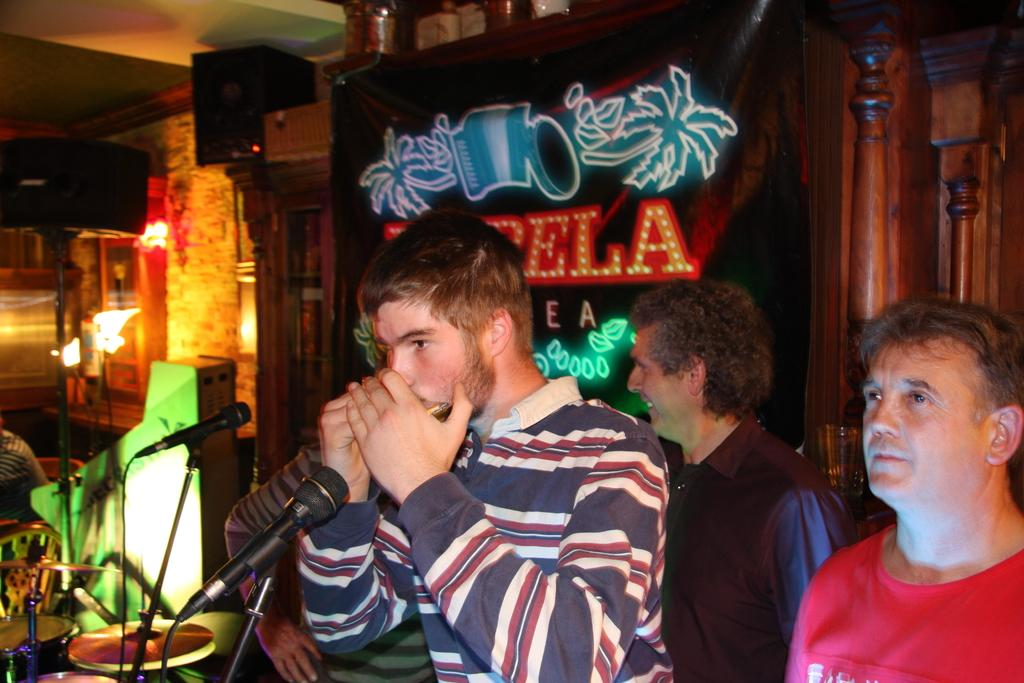What can be seen in the image involving people? There are people standing in the image. What objects are present for the purpose of amplifying sound? There are two microphones in the image. What type of seating is available in the image? There are chairs in the image. What can be seen in the background of the image? There is a poster in the background of the image. What architectural features are present in the image? There are two wooden pillars in the image. What type of string is being played by the people in the image? There is no string or musical instrument being played in the image; the people are likely standing for another purpose. 